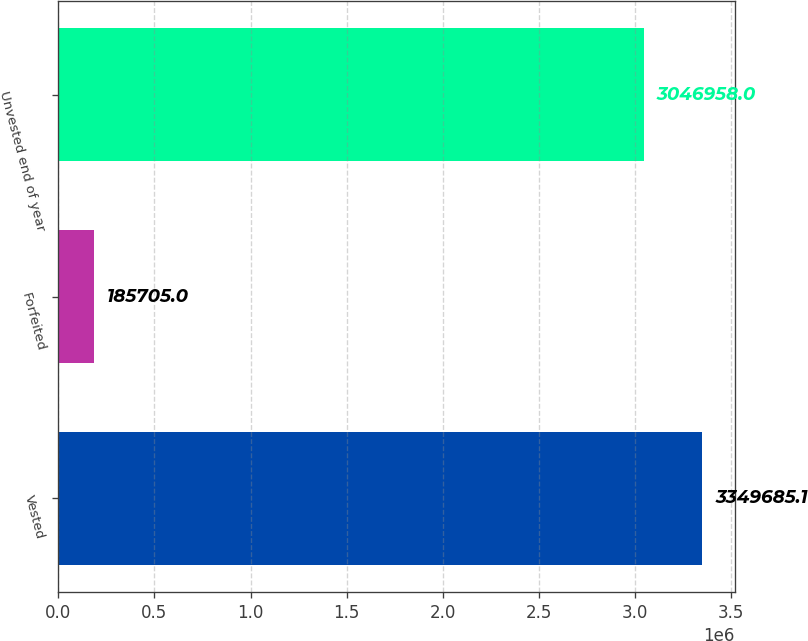Convert chart to OTSL. <chart><loc_0><loc_0><loc_500><loc_500><bar_chart><fcel>Vested<fcel>Forfeited<fcel>Unvested end of year<nl><fcel>3.34969e+06<fcel>185705<fcel>3.04696e+06<nl></chart> 